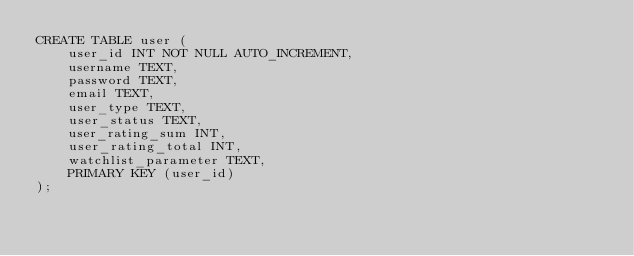<code> <loc_0><loc_0><loc_500><loc_500><_SQL_>CREATE TABLE user (
    user_id INT NOT NULL AUTO_INCREMENT,
    username TEXT,
    password TEXT,
    email TEXT,
    user_type TEXT,
    user_status TEXT,
    user_rating_sum INT,
    user_rating_total INT,
    watchlist_parameter TEXT,
    PRIMARY KEY (user_id)
);
</code> 